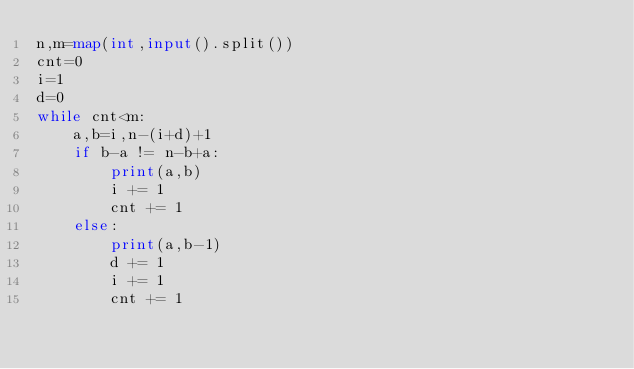Convert code to text. <code><loc_0><loc_0><loc_500><loc_500><_Python_>n,m=map(int,input().split())
cnt=0
i=1
d=0
while cnt<m:
    a,b=i,n-(i+d)+1
    if b-a != n-b+a:
        print(a,b)
        i += 1
        cnt += 1
    else:
        print(a,b-1)
        d += 1
        i += 1
        cnt += 1
</code> 